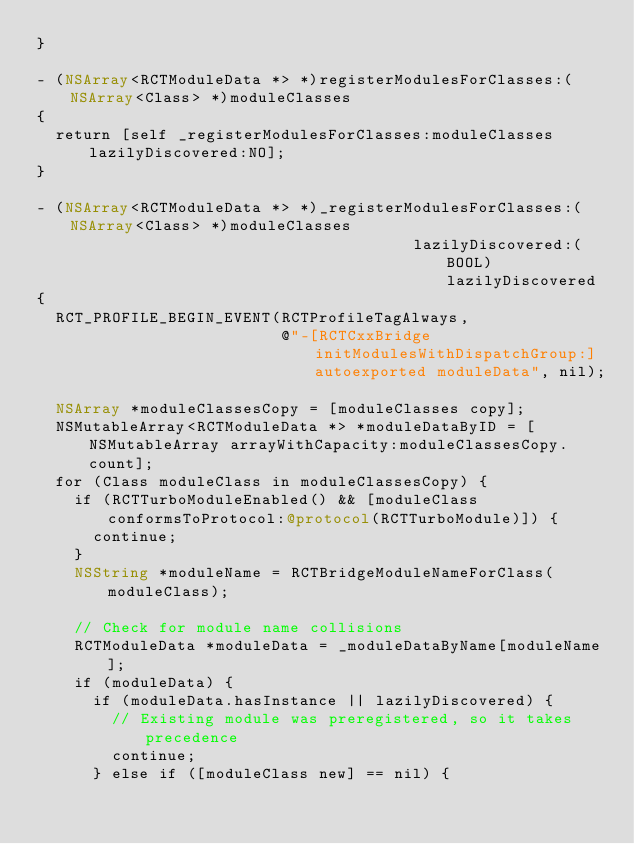<code> <loc_0><loc_0><loc_500><loc_500><_ObjectiveC_>}

- (NSArray<RCTModuleData *> *)registerModulesForClasses:(NSArray<Class> *)moduleClasses
{
  return [self _registerModulesForClasses:moduleClasses lazilyDiscovered:NO];
}

- (NSArray<RCTModuleData *> *)_registerModulesForClasses:(NSArray<Class> *)moduleClasses
                                        lazilyDiscovered:(BOOL)lazilyDiscovered
{
  RCT_PROFILE_BEGIN_EVENT(RCTProfileTagAlways,
                          @"-[RCTCxxBridge initModulesWithDispatchGroup:] autoexported moduleData", nil);

  NSArray *moduleClassesCopy = [moduleClasses copy];
  NSMutableArray<RCTModuleData *> *moduleDataByID = [NSMutableArray arrayWithCapacity:moduleClassesCopy.count];
  for (Class moduleClass in moduleClassesCopy) {
    if (RCTTurboModuleEnabled() && [moduleClass conformsToProtocol:@protocol(RCTTurboModule)]) {
      continue;
    }
    NSString *moduleName = RCTBridgeModuleNameForClass(moduleClass);

    // Check for module name collisions
    RCTModuleData *moduleData = _moduleDataByName[moduleName];
    if (moduleData) {
      if (moduleData.hasInstance || lazilyDiscovered) {
        // Existing module was preregistered, so it takes precedence
        continue;
      } else if ([moduleClass new] == nil) {</code> 